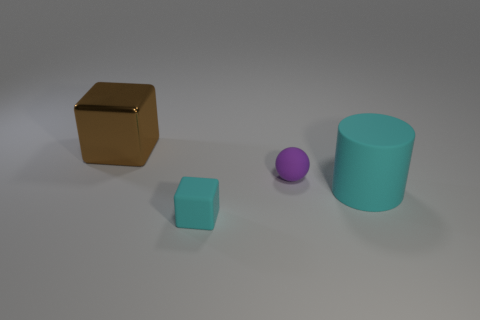Is the cube that is in front of the brown metallic cube made of the same material as the block behind the cylinder?
Offer a terse response. No. What number of other things are the same color as the big cube?
Offer a very short reply. 0. How many things are matte objects that are behind the large cyan matte thing or objects behind the tiny block?
Keep it short and to the point. 3. How big is the cyan matte thing that is right of the cyan rubber object left of the cyan rubber cylinder?
Your answer should be very brief. Large. The purple matte sphere has what size?
Ensure brevity in your answer.  Small. Does the thing that is in front of the big cyan cylinder have the same color as the big thing on the right side of the brown shiny object?
Offer a terse response. Yes. How many other things are made of the same material as the large brown object?
Give a very brief answer. 0. Is there a cyan object?
Offer a terse response. Yes. Do the big object that is right of the shiny object and the small purple ball have the same material?
Your response must be concise. Yes. There is another tiny object that is the same shape as the metal thing; what material is it?
Your response must be concise. Rubber. 